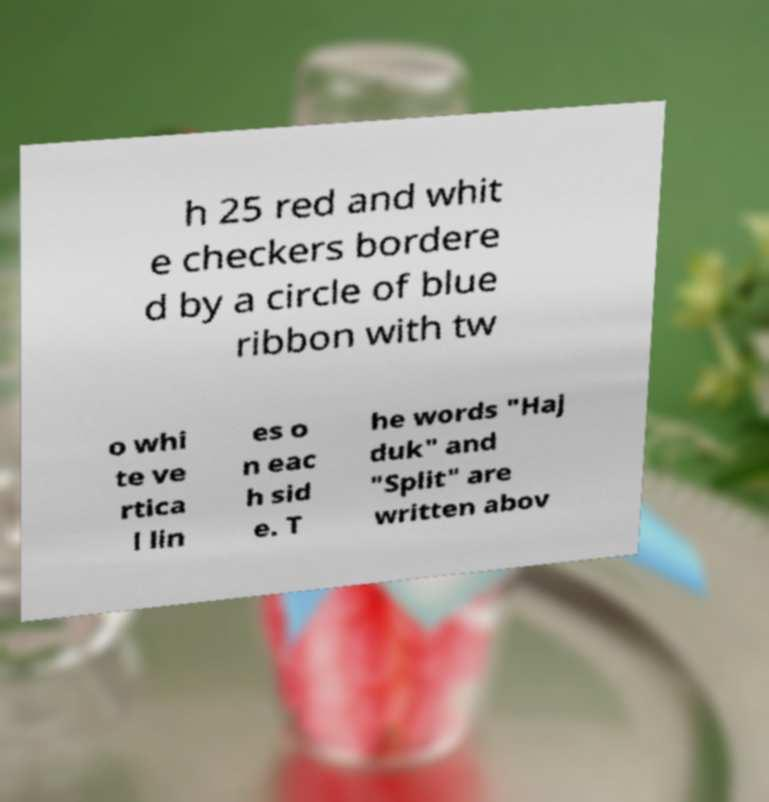Could you assist in decoding the text presented in this image and type it out clearly? h 25 red and whit e checkers bordere d by a circle of blue ribbon with tw o whi te ve rtica l lin es o n eac h sid e. T he words "Haj duk" and "Split" are written abov 